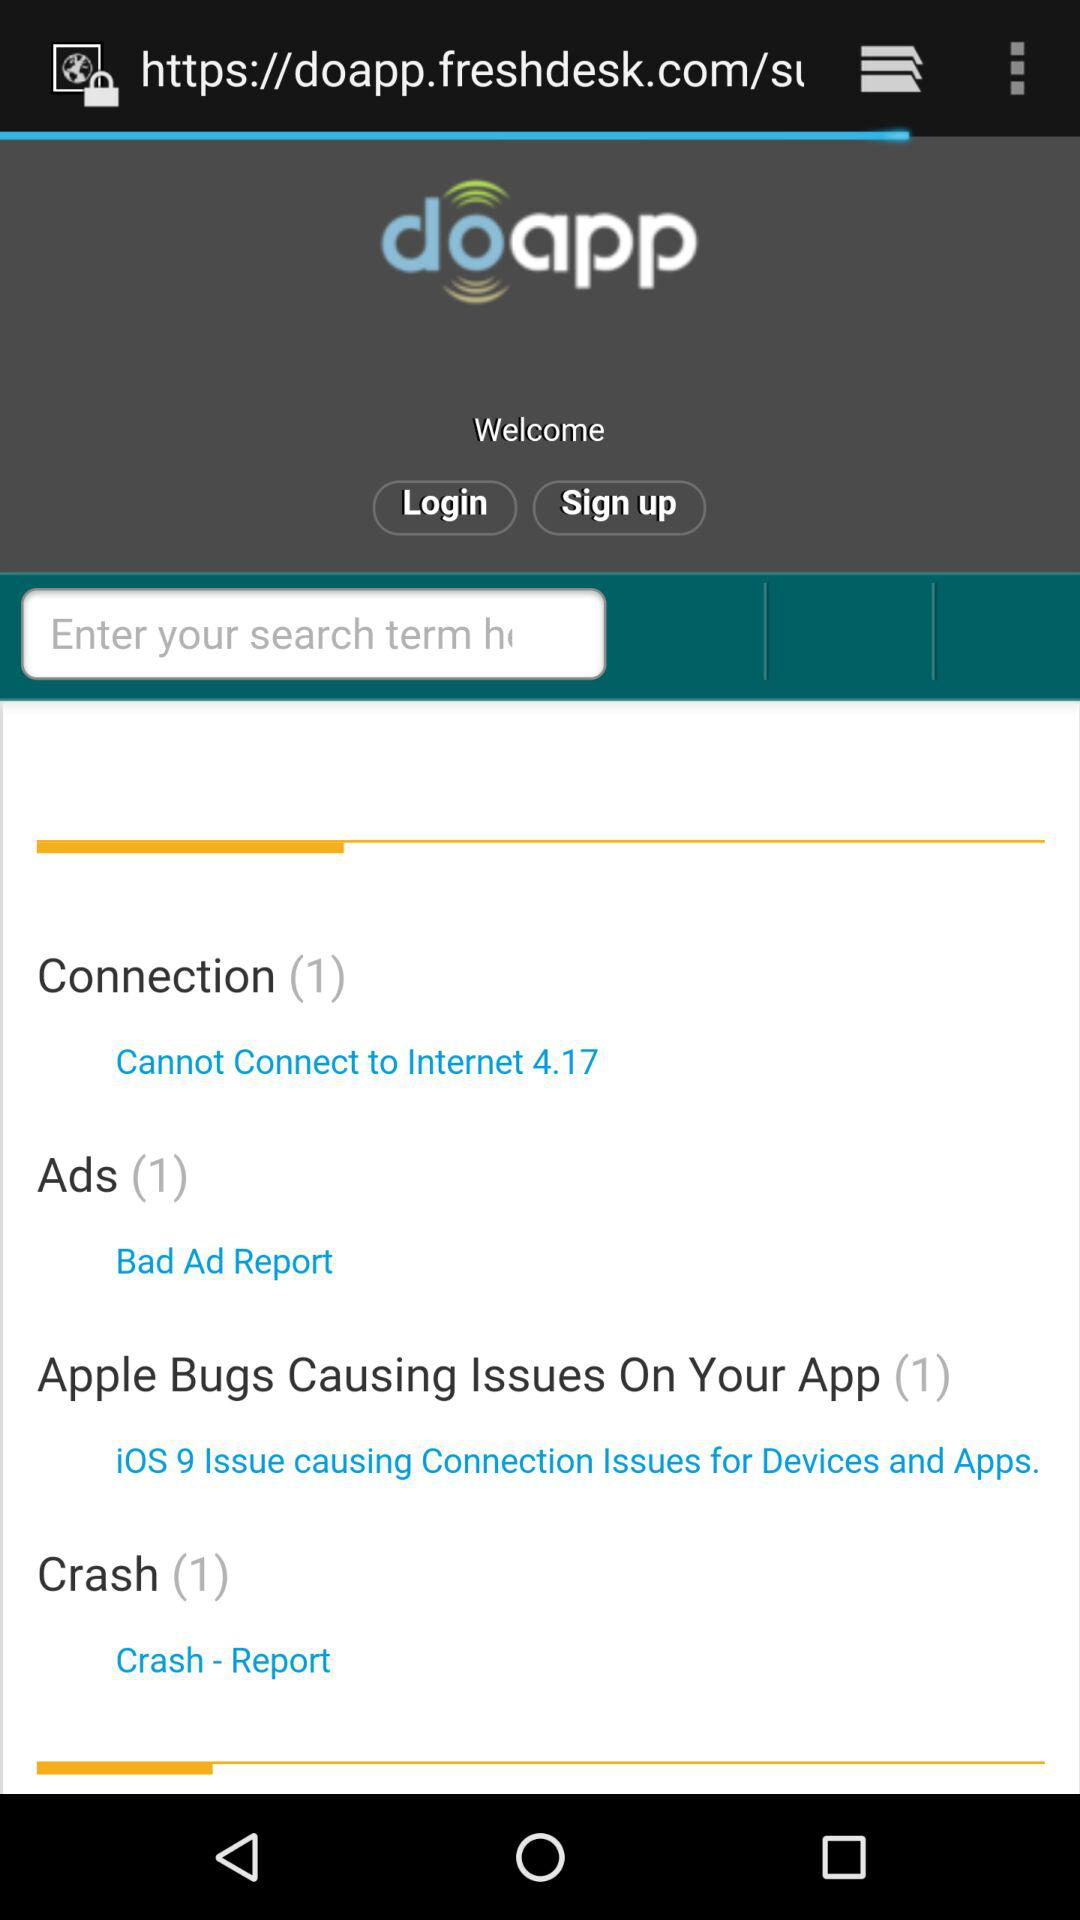What's the number of connections? The number of connections is 1. 